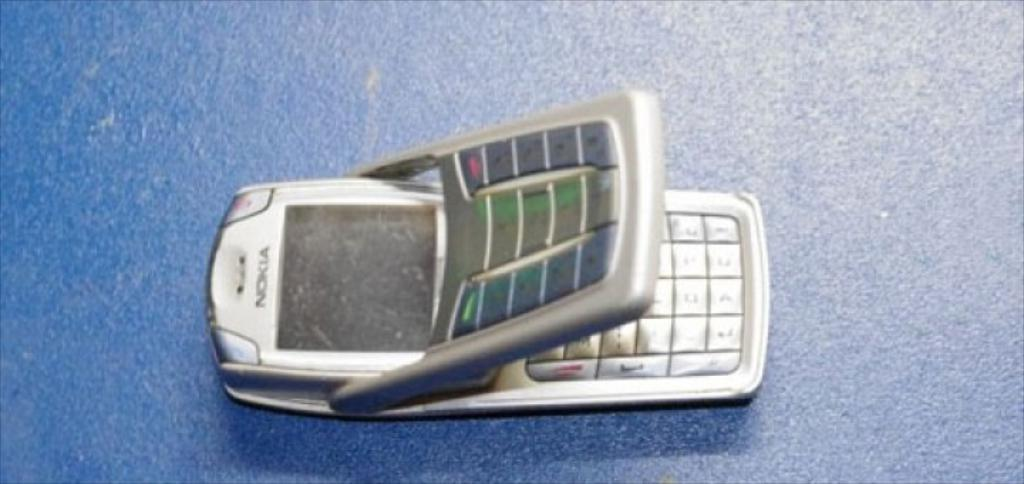What electronic device is visible in the image? There is a mobile phone in the image. Where is the mobile phone located? The mobile phone is on the floor. What color is the background of the image? The background of the image is blue in color. What type of silk fabric is draped over the mobile phone in the image? There is no silk fabric present in the image; the mobile phone is on the floor without any additional items covering it. 